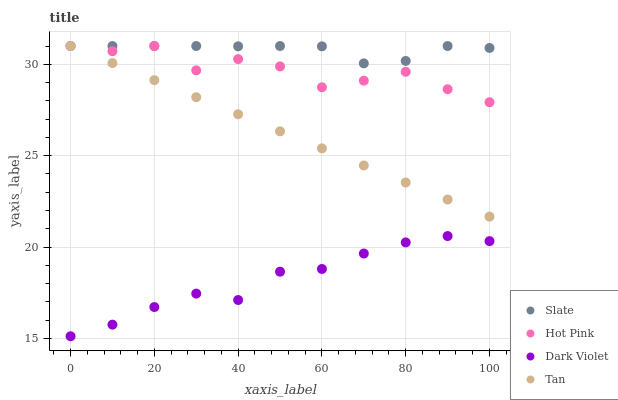Does Dark Violet have the minimum area under the curve?
Answer yes or no. Yes. Does Slate have the maximum area under the curve?
Answer yes or no. Yes. Does Hot Pink have the minimum area under the curve?
Answer yes or no. No. Does Hot Pink have the maximum area under the curve?
Answer yes or no. No. Is Tan the smoothest?
Answer yes or no. Yes. Is Hot Pink the roughest?
Answer yes or no. Yes. Is Hot Pink the smoothest?
Answer yes or no. No. Is Tan the roughest?
Answer yes or no. No. Does Dark Violet have the lowest value?
Answer yes or no. Yes. Does Hot Pink have the lowest value?
Answer yes or no. No. Does Tan have the highest value?
Answer yes or no. Yes. Does Dark Violet have the highest value?
Answer yes or no. No. Is Dark Violet less than Slate?
Answer yes or no. Yes. Is Tan greater than Dark Violet?
Answer yes or no. Yes. Does Tan intersect Hot Pink?
Answer yes or no. Yes. Is Tan less than Hot Pink?
Answer yes or no. No. Is Tan greater than Hot Pink?
Answer yes or no. No. Does Dark Violet intersect Slate?
Answer yes or no. No. 